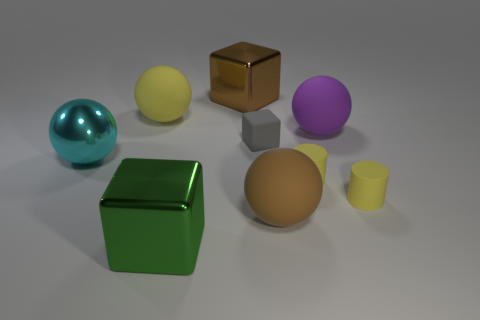Add 1 large gray metal cylinders. How many objects exist? 10 Subtract all balls. How many objects are left? 5 Subtract all tiny yellow rubber cylinders. Subtract all big yellow rubber balls. How many objects are left? 6 Add 7 large cyan objects. How many large cyan objects are left? 8 Add 2 big yellow balls. How many big yellow balls exist? 3 Subtract 1 brown blocks. How many objects are left? 8 